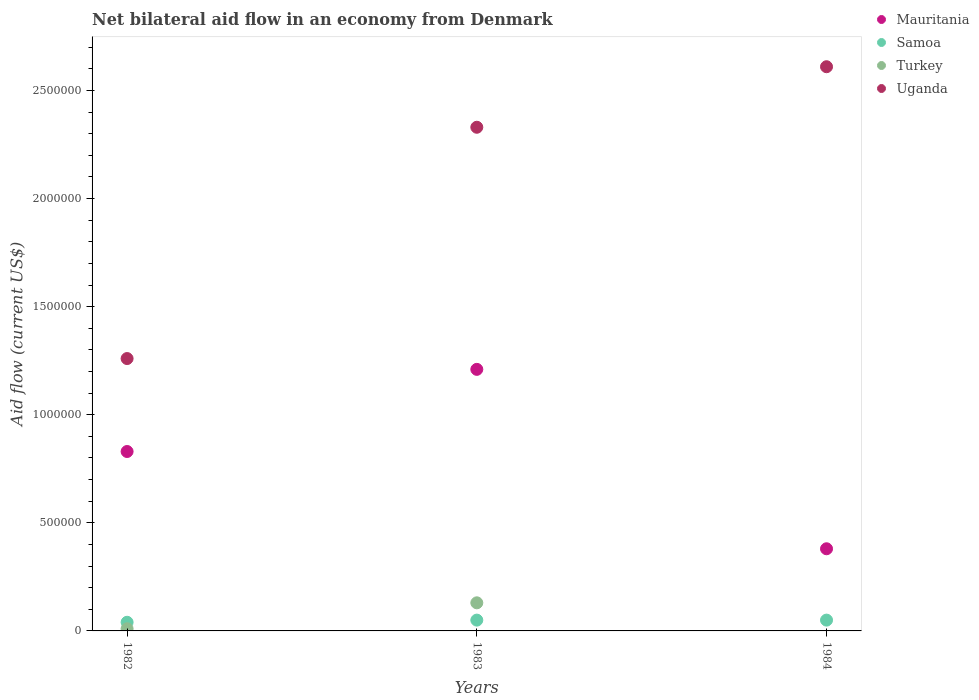How many different coloured dotlines are there?
Give a very brief answer. 4. Is the number of dotlines equal to the number of legend labels?
Make the answer very short. No. What is the net bilateral aid flow in Uganda in 1983?
Make the answer very short. 2.33e+06. Across all years, what is the maximum net bilateral aid flow in Samoa?
Offer a terse response. 5.00e+04. Across all years, what is the minimum net bilateral aid flow in Turkey?
Make the answer very short. 0. What is the total net bilateral aid flow in Mauritania in the graph?
Ensure brevity in your answer.  2.42e+06. What is the difference between the net bilateral aid flow in Uganda in 1983 and that in 1984?
Give a very brief answer. -2.80e+05. What is the difference between the net bilateral aid flow in Samoa in 1984 and the net bilateral aid flow in Mauritania in 1983?
Your response must be concise. -1.16e+06. What is the average net bilateral aid flow in Samoa per year?
Make the answer very short. 4.67e+04. In the year 1982, what is the difference between the net bilateral aid flow in Turkey and net bilateral aid flow in Mauritania?
Provide a short and direct response. -8.20e+05. What is the ratio of the net bilateral aid flow in Uganda in 1982 to that in 1983?
Your answer should be compact. 0.54. Is the net bilateral aid flow in Samoa in 1983 less than that in 1984?
Offer a very short reply. No. Is the sum of the net bilateral aid flow in Mauritania in 1982 and 1983 greater than the maximum net bilateral aid flow in Turkey across all years?
Keep it short and to the point. Yes. Is it the case that in every year, the sum of the net bilateral aid flow in Mauritania and net bilateral aid flow in Samoa  is greater than the net bilateral aid flow in Turkey?
Offer a terse response. Yes. Does the net bilateral aid flow in Mauritania monotonically increase over the years?
Your answer should be compact. No. Is the net bilateral aid flow in Turkey strictly less than the net bilateral aid flow in Uganda over the years?
Your answer should be very brief. Yes. Does the graph contain any zero values?
Offer a terse response. Yes. How many legend labels are there?
Make the answer very short. 4. What is the title of the graph?
Provide a short and direct response. Net bilateral aid flow in an economy from Denmark. What is the label or title of the X-axis?
Your answer should be very brief. Years. What is the Aid flow (current US$) in Mauritania in 1982?
Your response must be concise. 8.30e+05. What is the Aid flow (current US$) in Samoa in 1982?
Provide a succinct answer. 4.00e+04. What is the Aid flow (current US$) of Uganda in 1982?
Offer a very short reply. 1.26e+06. What is the Aid flow (current US$) in Mauritania in 1983?
Make the answer very short. 1.21e+06. What is the Aid flow (current US$) of Samoa in 1983?
Your response must be concise. 5.00e+04. What is the Aid flow (current US$) in Turkey in 1983?
Offer a very short reply. 1.30e+05. What is the Aid flow (current US$) of Uganda in 1983?
Provide a short and direct response. 2.33e+06. What is the Aid flow (current US$) of Samoa in 1984?
Your answer should be very brief. 5.00e+04. What is the Aid flow (current US$) of Uganda in 1984?
Give a very brief answer. 2.61e+06. Across all years, what is the maximum Aid flow (current US$) of Mauritania?
Keep it short and to the point. 1.21e+06. Across all years, what is the maximum Aid flow (current US$) of Uganda?
Keep it short and to the point. 2.61e+06. Across all years, what is the minimum Aid flow (current US$) in Samoa?
Offer a terse response. 4.00e+04. Across all years, what is the minimum Aid flow (current US$) in Uganda?
Your answer should be compact. 1.26e+06. What is the total Aid flow (current US$) of Mauritania in the graph?
Your answer should be compact. 2.42e+06. What is the total Aid flow (current US$) in Uganda in the graph?
Make the answer very short. 6.20e+06. What is the difference between the Aid flow (current US$) of Mauritania in 1982 and that in 1983?
Your answer should be compact. -3.80e+05. What is the difference between the Aid flow (current US$) in Samoa in 1982 and that in 1983?
Offer a terse response. -10000. What is the difference between the Aid flow (current US$) in Turkey in 1982 and that in 1983?
Provide a short and direct response. -1.20e+05. What is the difference between the Aid flow (current US$) of Uganda in 1982 and that in 1983?
Your answer should be very brief. -1.07e+06. What is the difference between the Aid flow (current US$) of Uganda in 1982 and that in 1984?
Make the answer very short. -1.35e+06. What is the difference between the Aid flow (current US$) in Mauritania in 1983 and that in 1984?
Your answer should be compact. 8.30e+05. What is the difference between the Aid flow (current US$) in Samoa in 1983 and that in 1984?
Make the answer very short. 0. What is the difference between the Aid flow (current US$) in Uganda in 1983 and that in 1984?
Your answer should be very brief. -2.80e+05. What is the difference between the Aid flow (current US$) of Mauritania in 1982 and the Aid flow (current US$) of Samoa in 1983?
Provide a succinct answer. 7.80e+05. What is the difference between the Aid flow (current US$) in Mauritania in 1982 and the Aid flow (current US$) in Uganda in 1983?
Offer a terse response. -1.50e+06. What is the difference between the Aid flow (current US$) in Samoa in 1982 and the Aid flow (current US$) in Turkey in 1983?
Your answer should be very brief. -9.00e+04. What is the difference between the Aid flow (current US$) of Samoa in 1982 and the Aid flow (current US$) of Uganda in 1983?
Your answer should be very brief. -2.29e+06. What is the difference between the Aid flow (current US$) of Turkey in 1982 and the Aid flow (current US$) of Uganda in 1983?
Keep it short and to the point. -2.32e+06. What is the difference between the Aid flow (current US$) in Mauritania in 1982 and the Aid flow (current US$) in Samoa in 1984?
Provide a succinct answer. 7.80e+05. What is the difference between the Aid flow (current US$) in Mauritania in 1982 and the Aid flow (current US$) in Uganda in 1984?
Provide a succinct answer. -1.78e+06. What is the difference between the Aid flow (current US$) of Samoa in 1982 and the Aid flow (current US$) of Uganda in 1984?
Your answer should be compact. -2.57e+06. What is the difference between the Aid flow (current US$) in Turkey in 1982 and the Aid flow (current US$) in Uganda in 1984?
Make the answer very short. -2.60e+06. What is the difference between the Aid flow (current US$) of Mauritania in 1983 and the Aid flow (current US$) of Samoa in 1984?
Provide a succinct answer. 1.16e+06. What is the difference between the Aid flow (current US$) in Mauritania in 1983 and the Aid flow (current US$) in Uganda in 1984?
Offer a very short reply. -1.40e+06. What is the difference between the Aid flow (current US$) of Samoa in 1983 and the Aid flow (current US$) of Uganda in 1984?
Provide a short and direct response. -2.56e+06. What is the difference between the Aid flow (current US$) of Turkey in 1983 and the Aid flow (current US$) of Uganda in 1984?
Provide a short and direct response. -2.48e+06. What is the average Aid flow (current US$) of Mauritania per year?
Your response must be concise. 8.07e+05. What is the average Aid flow (current US$) in Samoa per year?
Provide a short and direct response. 4.67e+04. What is the average Aid flow (current US$) of Turkey per year?
Offer a very short reply. 4.67e+04. What is the average Aid flow (current US$) of Uganda per year?
Provide a succinct answer. 2.07e+06. In the year 1982, what is the difference between the Aid flow (current US$) in Mauritania and Aid flow (current US$) in Samoa?
Provide a short and direct response. 7.90e+05. In the year 1982, what is the difference between the Aid flow (current US$) of Mauritania and Aid flow (current US$) of Turkey?
Give a very brief answer. 8.20e+05. In the year 1982, what is the difference between the Aid flow (current US$) of Mauritania and Aid flow (current US$) of Uganda?
Give a very brief answer. -4.30e+05. In the year 1982, what is the difference between the Aid flow (current US$) in Samoa and Aid flow (current US$) in Uganda?
Make the answer very short. -1.22e+06. In the year 1982, what is the difference between the Aid flow (current US$) of Turkey and Aid flow (current US$) of Uganda?
Ensure brevity in your answer.  -1.25e+06. In the year 1983, what is the difference between the Aid flow (current US$) of Mauritania and Aid flow (current US$) of Samoa?
Your answer should be very brief. 1.16e+06. In the year 1983, what is the difference between the Aid flow (current US$) in Mauritania and Aid flow (current US$) in Turkey?
Provide a short and direct response. 1.08e+06. In the year 1983, what is the difference between the Aid flow (current US$) in Mauritania and Aid flow (current US$) in Uganda?
Give a very brief answer. -1.12e+06. In the year 1983, what is the difference between the Aid flow (current US$) in Samoa and Aid flow (current US$) in Uganda?
Provide a succinct answer. -2.28e+06. In the year 1983, what is the difference between the Aid flow (current US$) of Turkey and Aid flow (current US$) of Uganda?
Offer a terse response. -2.20e+06. In the year 1984, what is the difference between the Aid flow (current US$) of Mauritania and Aid flow (current US$) of Uganda?
Keep it short and to the point. -2.23e+06. In the year 1984, what is the difference between the Aid flow (current US$) in Samoa and Aid flow (current US$) in Uganda?
Ensure brevity in your answer.  -2.56e+06. What is the ratio of the Aid flow (current US$) of Mauritania in 1982 to that in 1983?
Ensure brevity in your answer.  0.69. What is the ratio of the Aid flow (current US$) in Samoa in 1982 to that in 1983?
Offer a terse response. 0.8. What is the ratio of the Aid flow (current US$) in Turkey in 1982 to that in 1983?
Provide a succinct answer. 0.08. What is the ratio of the Aid flow (current US$) of Uganda in 1982 to that in 1983?
Your response must be concise. 0.54. What is the ratio of the Aid flow (current US$) in Mauritania in 1982 to that in 1984?
Offer a very short reply. 2.18. What is the ratio of the Aid flow (current US$) in Samoa in 1982 to that in 1984?
Your answer should be very brief. 0.8. What is the ratio of the Aid flow (current US$) in Uganda in 1982 to that in 1984?
Provide a short and direct response. 0.48. What is the ratio of the Aid flow (current US$) in Mauritania in 1983 to that in 1984?
Provide a succinct answer. 3.18. What is the ratio of the Aid flow (current US$) in Samoa in 1983 to that in 1984?
Offer a very short reply. 1. What is the ratio of the Aid flow (current US$) in Uganda in 1983 to that in 1984?
Offer a terse response. 0.89. What is the difference between the highest and the second highest Aid flow (current US$) in Samoa?
Give a very brief answer. 0. What is the difference between the highest and the second highest Aid flow (current US$) of Uganda?
Make the answer very short. 2.80e+05. What is the difference between the highest and the lowest Aid flow (current US$) in Mauritania?
Offer a terse response. 8.30e+05. What is the difference between the highest and the lowest Aid flow (current US$) of Samoa?
Offer a terse response. 10000. What is the difference between the highest and the lowest Aid flow (current US$) of Uganda?
Make the answer very short. 1.35e+06. 